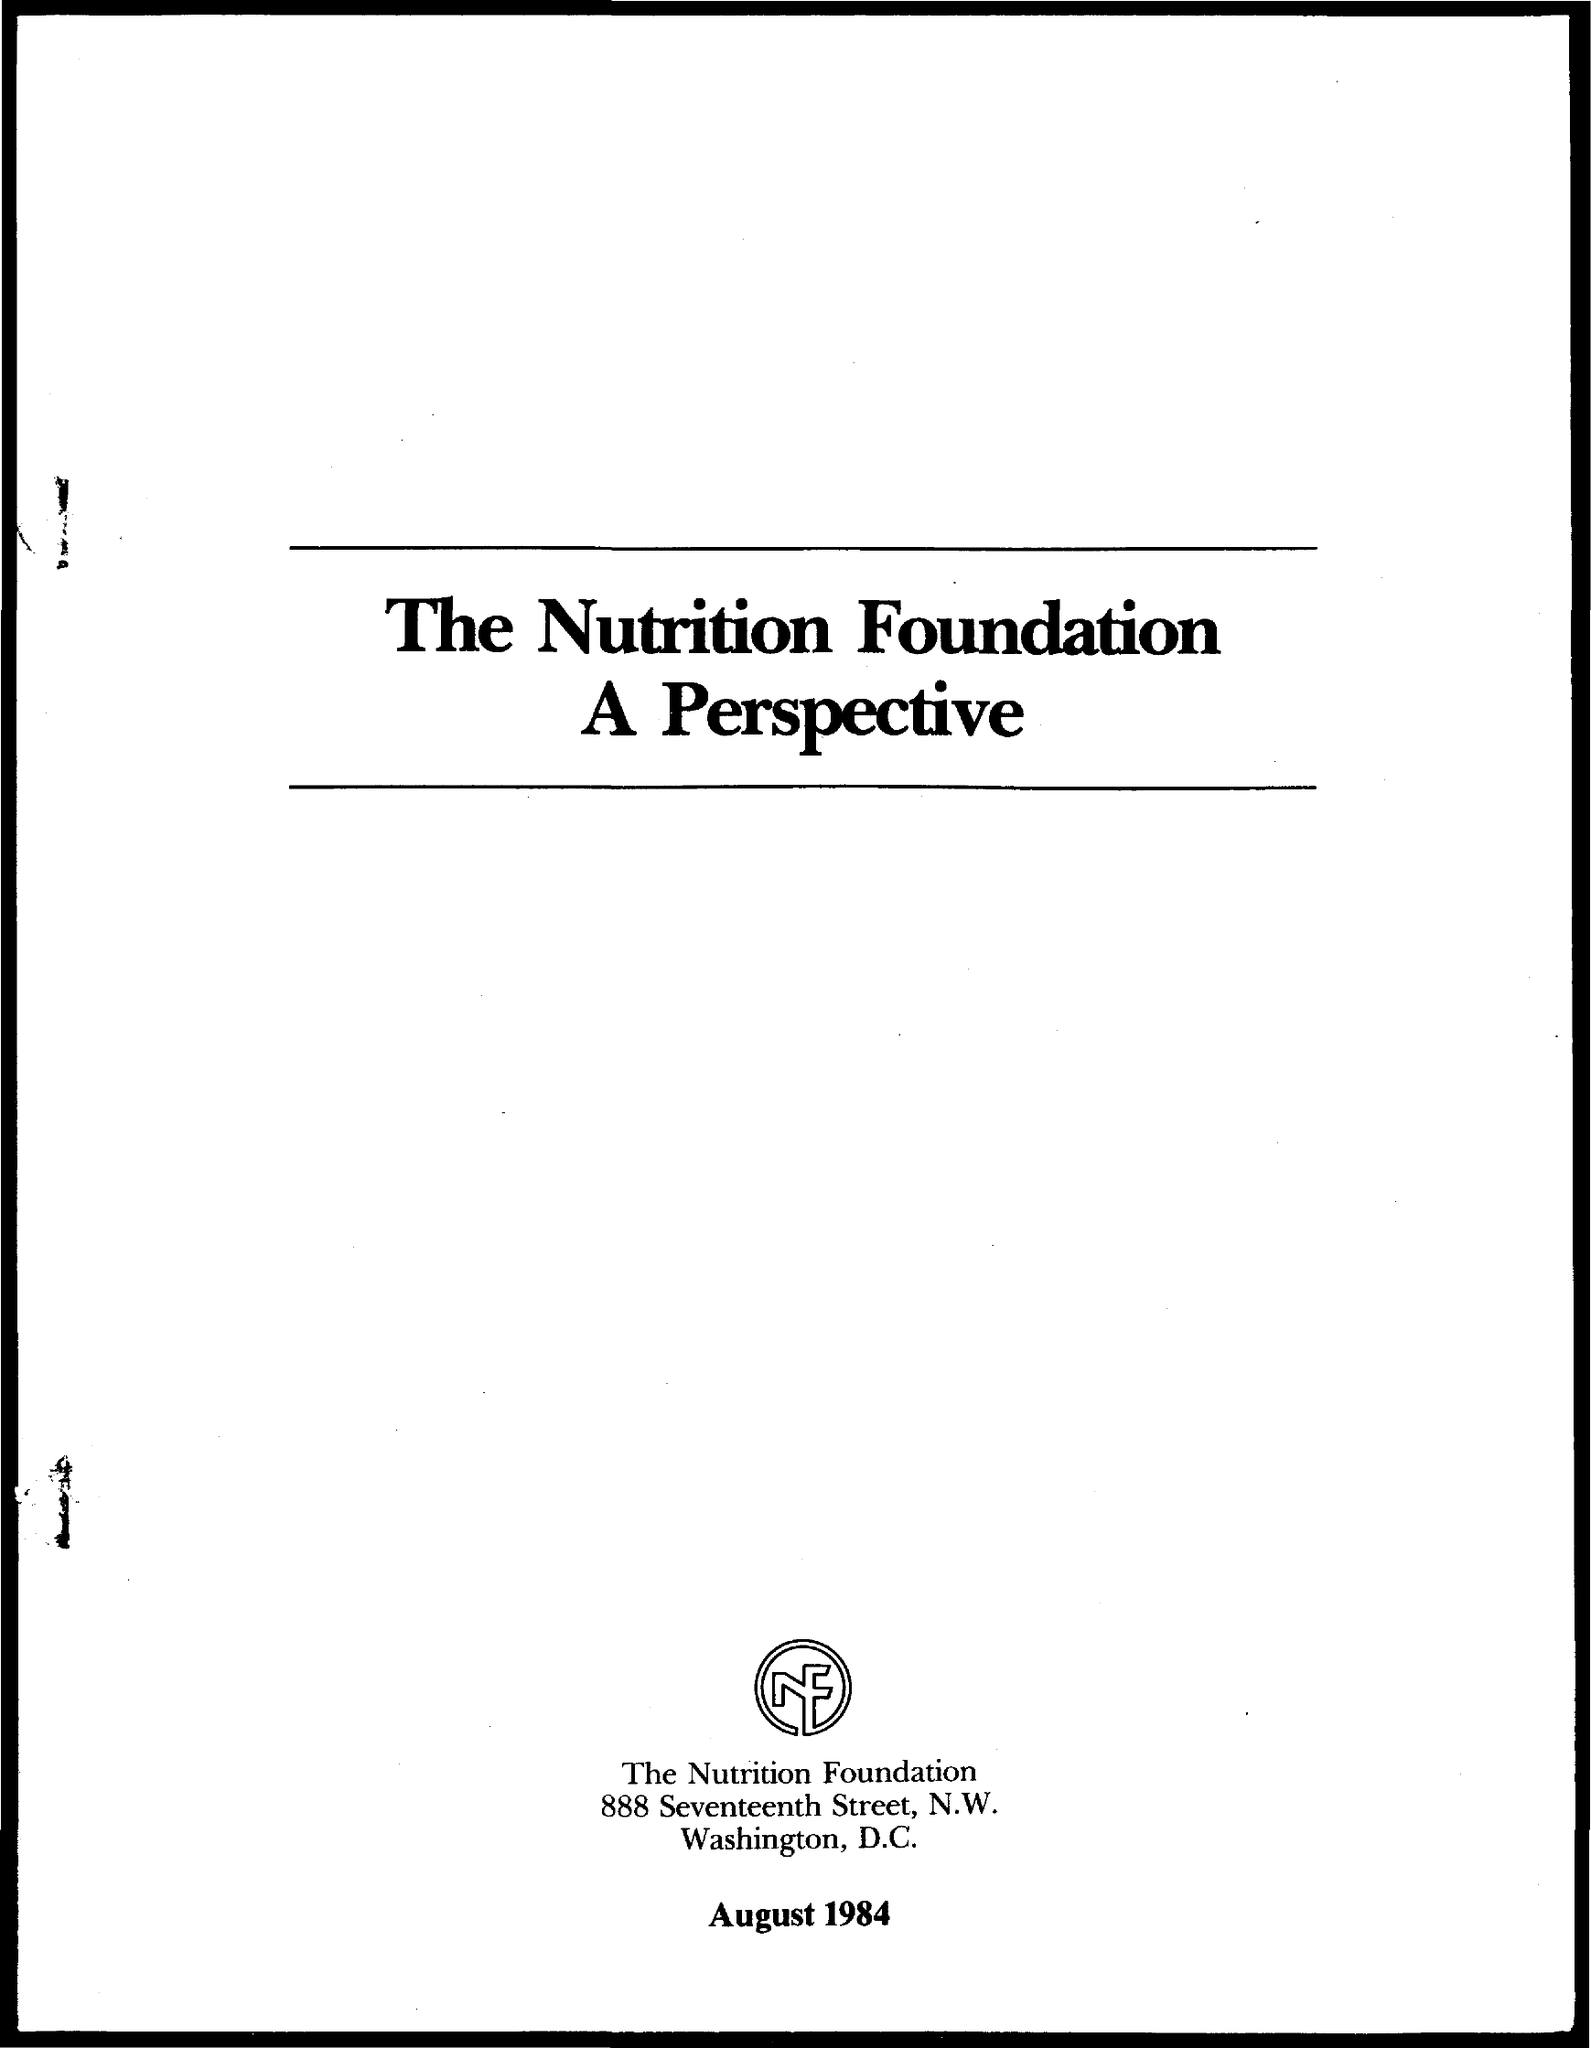Give some essential details in this illustration. The date on the document is August 1984. 